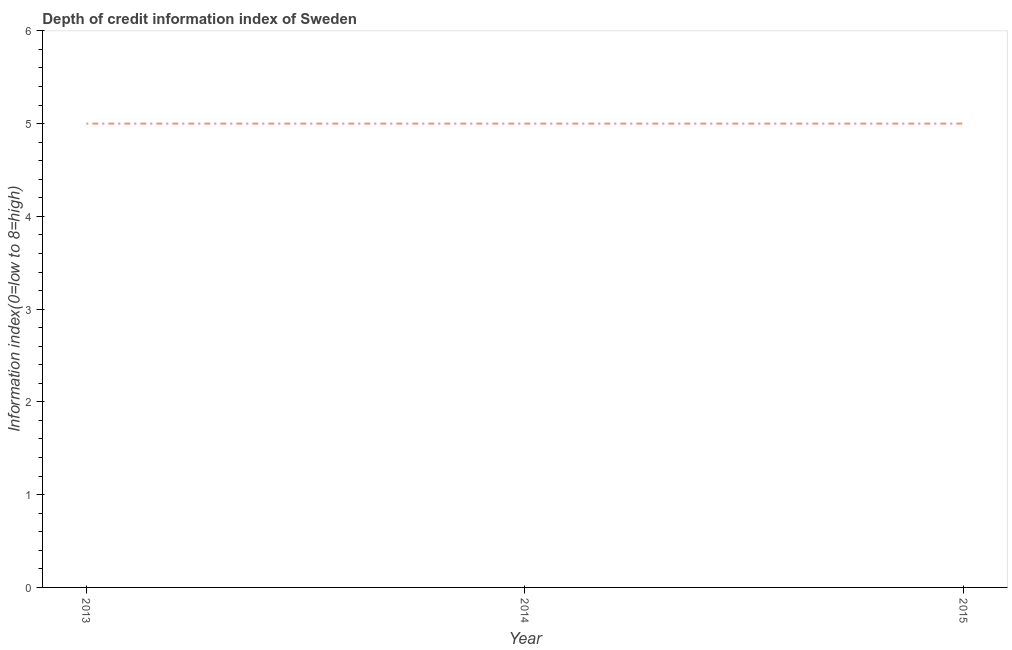What is the depth of credit information index in 2013?
Offer a very short reply. 5. Across all years, what is the maximum depth of credit information index?
Provide a short and direct response. 5. Across all years, what is the minimum depth of credit information index?
Offer a very short reply. 5. In which year was the depth of credit information index maximum?
Provide a succinct answer. 2013. What is the sum of the depth of credit information index?
Ensure brevity in your answer.  15. In how many years, is the depth of credit information index greater than 5.2 ?
Your response must be concise. 0. Do a majority of the years between 2013 and 2014 (inclusive) have depth of credit information index greater than 1 ?
Give a very brief answer. Yes. Is the depth of credit information index in 2014 less than that in 2015?
Give a very brief answer. No. In how many years, is the depth of credit information index greater than the average depth of credit information index taken over all years?
Your response must be concise. 0. Does the depth of credit information index monotonically increase over the years?
Keep it short and to the point. No. How many lines are there?
Your answer should be compact. 1. How many years are there in the graph?
Ensure brevity in your answer.  3. What is the title of the graph?
Your response must be concise. Depth of credit information index of Sweden. What is the label or title of the X-axis?
Keep it short and to the point. Year. What is the label or title of the Y-axis?
Ensure brevity in your answer.  Information index(0=low to 8=high). What is the difference between the Information index(0=low to 8=high) in 2013 and 2015?
Your answer should be compact. 0. What is the difference between the Information index(0=low to 8=high) in 2014 and 2015?
Your answer should be compact. 0. What is the ratio of the Information index(0=low to 8=high) in 2013 to that in 2014?
Offer a terse response. 1. What is the ratio of the Information index(0=low to 8=high) in 2013 to that in 2015?
Keep it short and to the point. 1. 